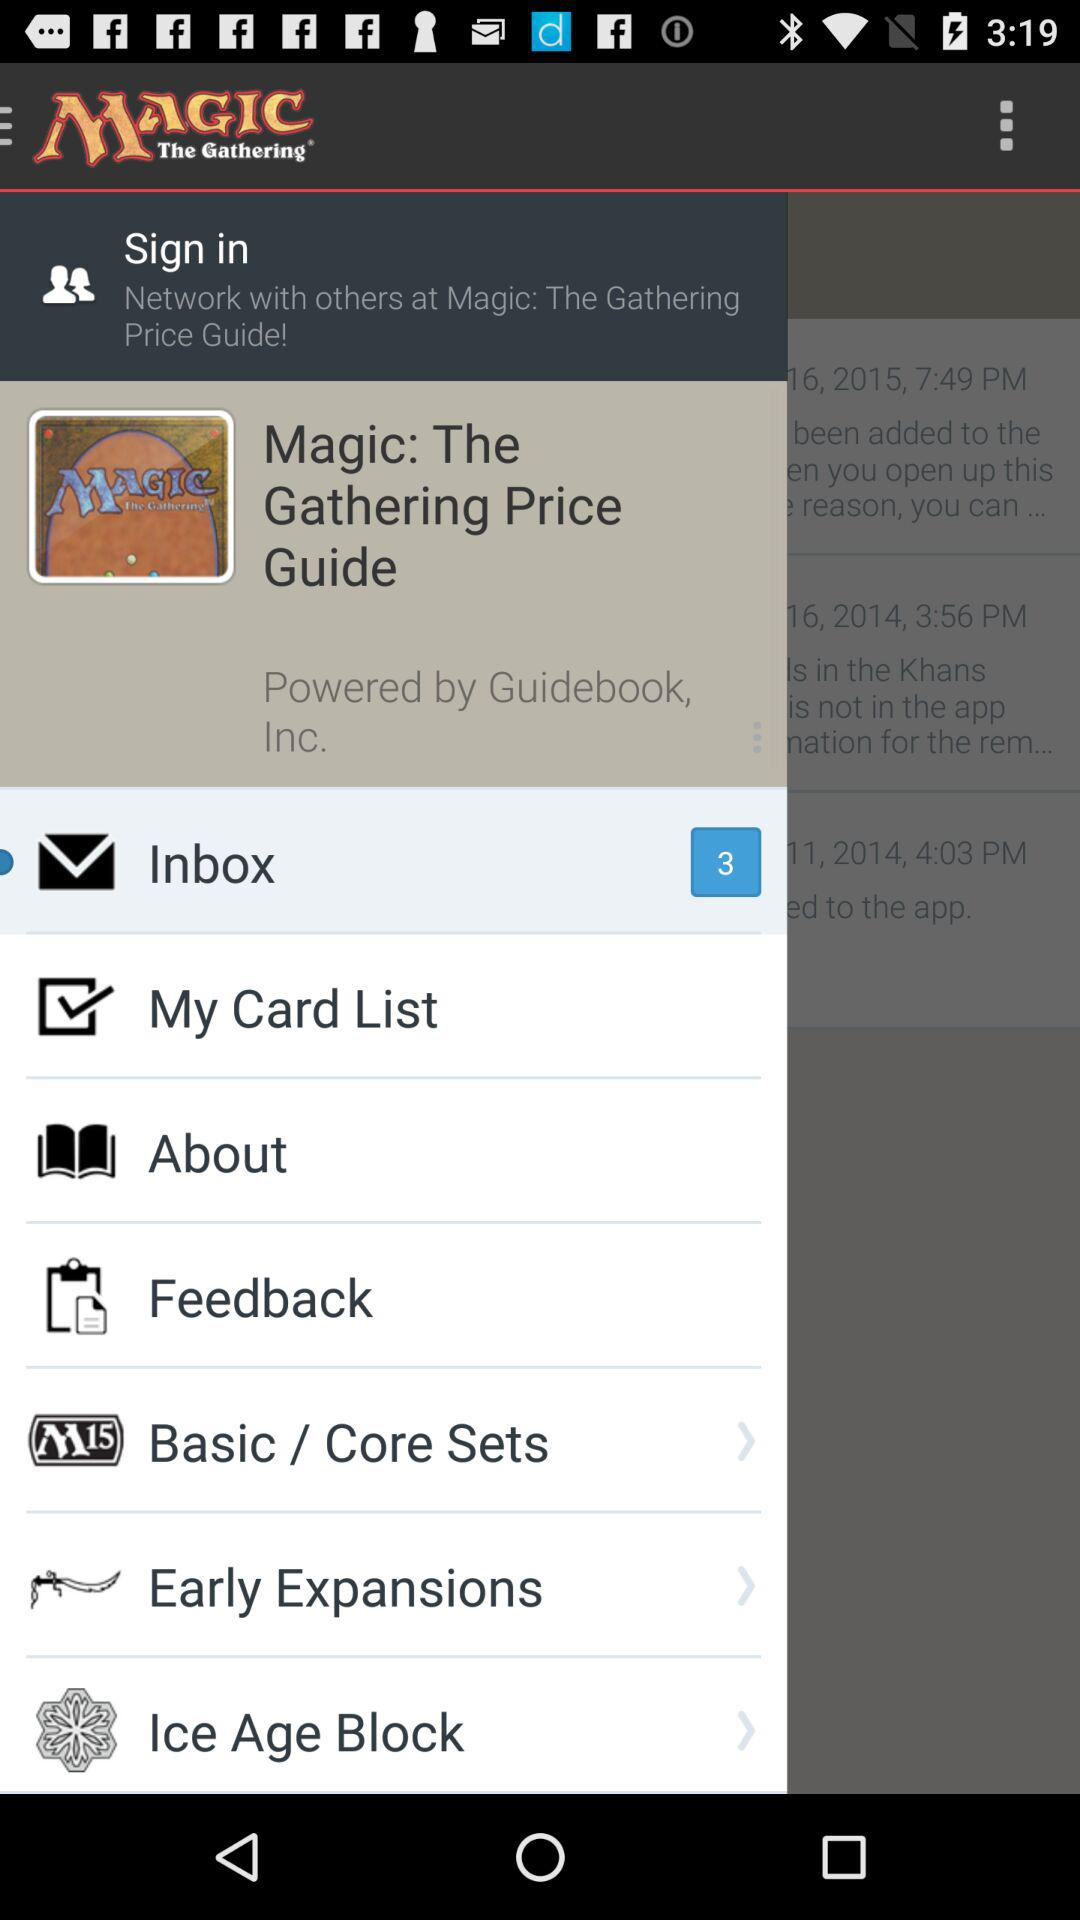What is the application name? The application name is "MAGIC The Gathering". 